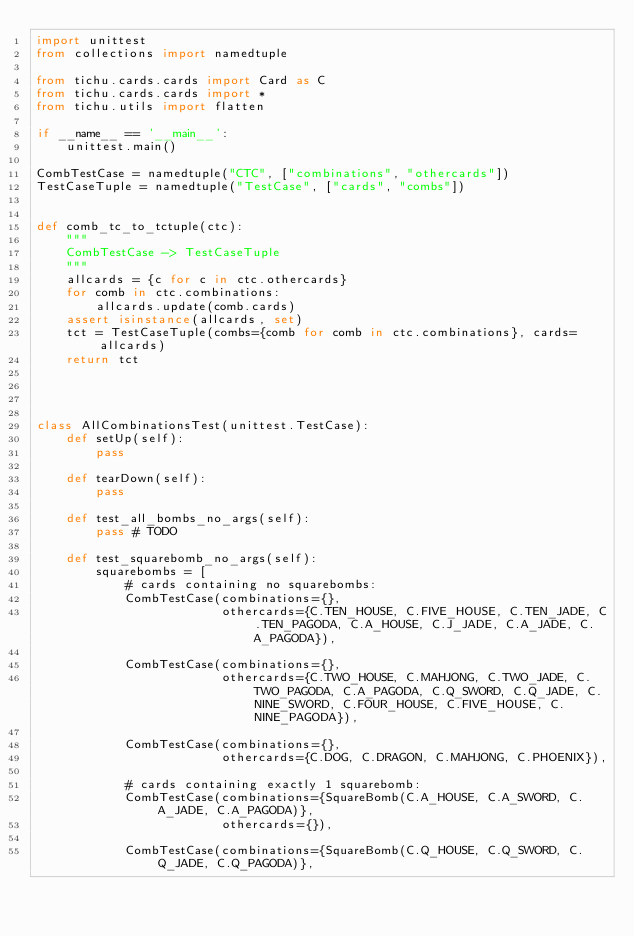Convert code to text. <code><loc_0><loc_0><loc_500><loc_500><_Python_>import unittest
from collections import namedtuple

from tichu.cards.cards import Card as C
from tichu.cards.cards import *
from tichu.utils import flatten

if __name__ == '__main__':
    unittest.main()

CombTestCase = namedtuple("CTC", ["combinations", "othercards"])
TestCaseTuple = namedtuple("TestCase", ["cards", "combs"])


def comb_tc_to_tctuple(ctc):
    """
    CombTestCase -> TestCaseTuple
    """
    allcards = {c for c in ctc.othercards}
    for comb in ctc.combinations:
        allcards.update(comb.cards)
    assert isinstance(allcards, set)
    tct = TestCaseTuple(combs={comb for comb in ctc.combinations}, cards=allcards)
    return tct




class AllCombinationsTest(unittest.TestCase):
    def setUp(self):
        pass

    def tearDown(self):
        pass

    def test_all_bombs_no_args(self):
        pass # TODO

    def test_squarebomb_no_args(self):
        squarebombs = [
            # cards containing no squarebombs:
            CombTestCase(combinations={},
                         othercards={C.TEN_HOUSE, C.FIVE_HOUSE, C.TEN_JADE, C.TEN_PAGODA, C.A_HOUSE, C.J_JADE, C.A_JADE, C.A_PAGODA}),

            CombTestCase(combinations={},
                         othercards={C.TWO_HOUSE, C.MAHJONG, C.TWO_JADE, C.TWO_PAGODA, C.A_PAGODA, C.Q_SWORD, C.Q_JADE, C.NINE_SWORD, C.FOUR_HOUSE, C.FIVE_HOUSE, C.NINE_PAGODA}),

            CombTestCase(combinations={},
                         othercards={C.DOG, C.DRAGON, C.MAHJONG, C.PHOENIX}),

            # cards containing exactly 1 squarebomb:
            CombTestCase(combinations={SquareBomb(C.A_HOUSE, C.A_SWORD, C.A_JADE, C.A_PAGODA)},
                         othercards={}),

            CombTestCase(combinations={SquareBomb(C.Q_HOUSE, C.Q_SWORD, C.Q_JADE, C.Q_PAGODA)},</code> 